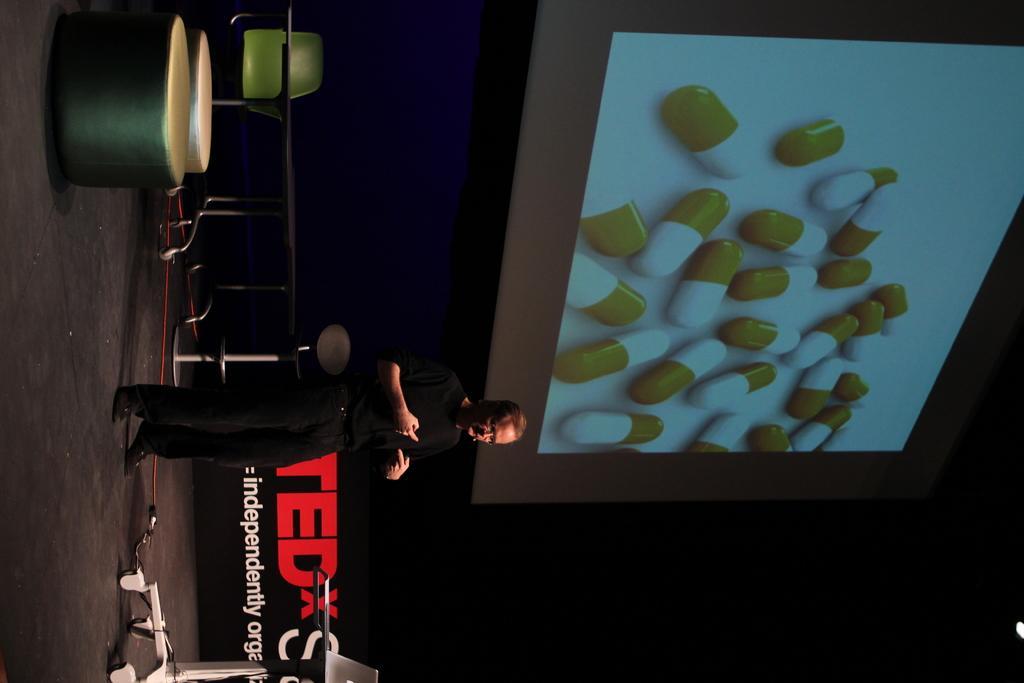How would you summarize this image in a sentence or two? In this image, I can see a person standing. This is a table. I can see the chairs and stools. At the bottom of the image, I can see a laptop placed on a table. I think this is a screen with the display. This looks like a board. 